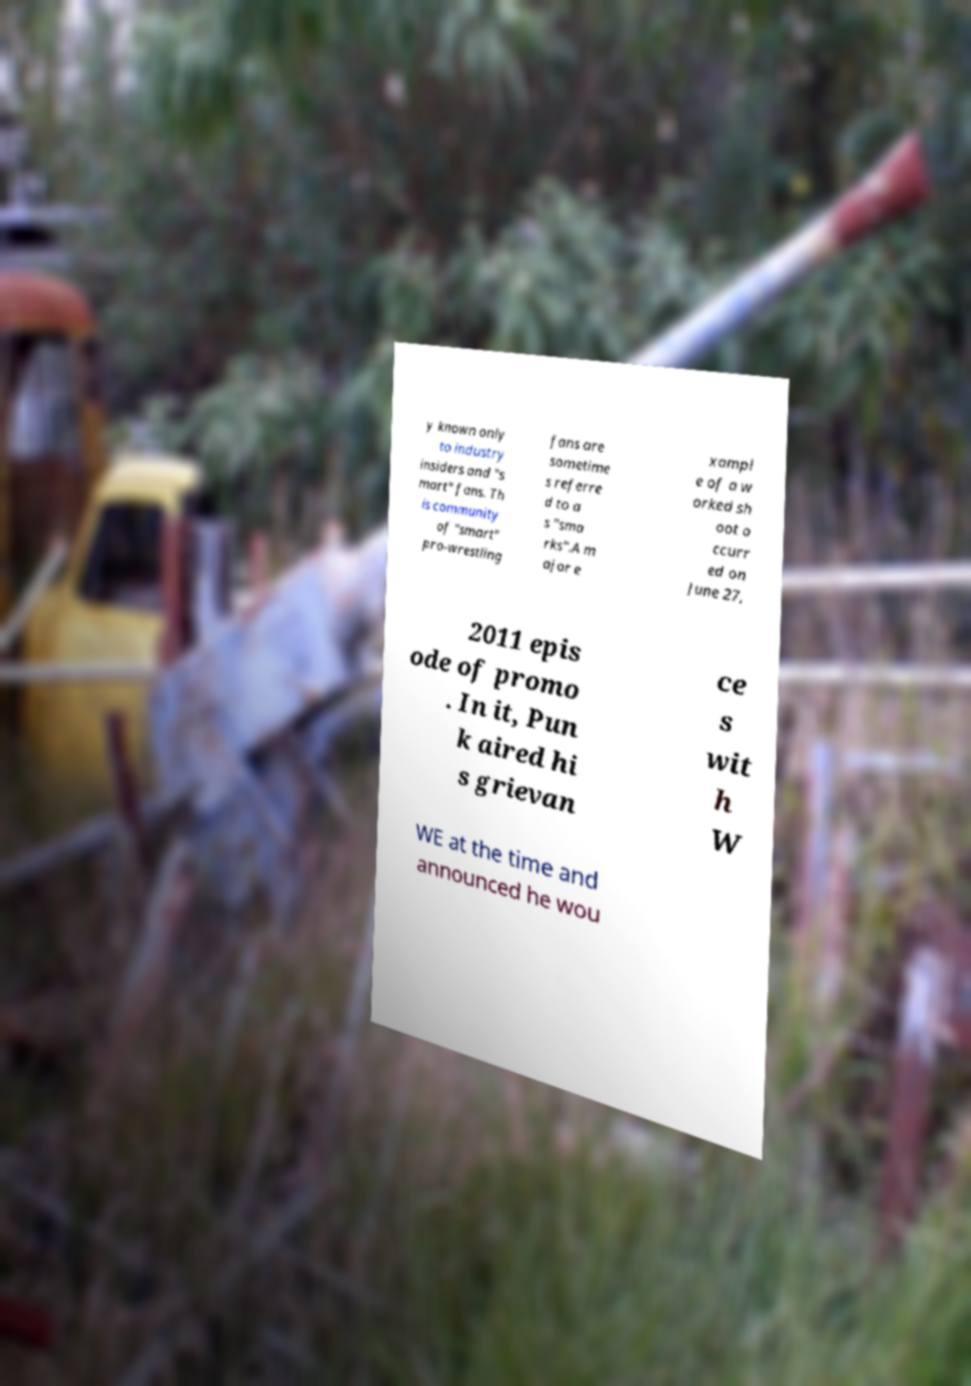Can you read and provide the text displayed in the image?This photo seems to have some interesting text. Can you extract and type it out for me? y known only to industry insiders and "s mart" fans. Th is community of "smart" pro-wrestling fans are sometime s referre d to a s "sma rks".A m ajor e xampl e of a w orked sh oot o ccurr ed on June 27, 2011 epis ode of promo . In it, Pun k aired hi s grievan ce s wit h W WE at the time and announced he wou 